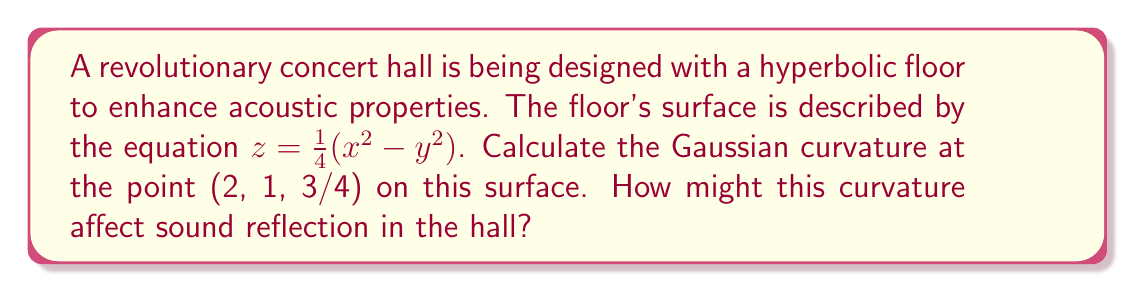Give your solution to this math problem. To calculate the Gaussian curvature of the hyperbolic surface, we'll follow these steps:

1) The surface is given by $z = f(x,y) = \frac{1}{4}(x^2 - y^2)$

2) We need to calculate the partial derivatives:
   $f_x = \frac{\partial f}{\partial x} = \frac{1}{2}x$
   $f_y = \frac{\partial f}{\partial y} = -\frac{1}{2}y$
   $f_{xx} = \frac{\partial^2 f}{\partial x^2} = \frac{1}{2}$
   $f_{yy} = \frac{\partial^2 f}{\partial y^2} = -\frac{1}{2}$
   $f_{xy} = f_{yx} = \frac{\partial^2 f}{\partial x \partial y} = 0$

3) The Gaussian curvature K is given by:
   $$K = \frac{f_{xx}f_{yy} - f_{xy}^2}{(1 + f_x^2 + f_y^2)^2}$$

4) Substituting the values at point (2, 1, 3/4):
   $$K = \frac{(\frac{1}{2})(-\frac{1}{2}) - 0^2}{(1 + (1)^2 + (-\frac{1}{2})^2)^2}$$

5) Simplifying:
   $$K = \frac{-\frac{1}{4}}{(1 + 1 + \frac{1}{4})^2} = \frac{-\frac{1}{4}}{(\frac{9}{4})^2} = -\frac{4}{81}$$

The negative curvature indicates that the surface is saddle-shaped at this point. This hyperbolic curvature can help disperse sound waves in multiple directions, potentially improving acoustic distribution throughout the concert hall. It may also reduce unwanted echoes and create a more immersive sound experience for the audience.
Answer: $K = -\frac{4}{81}$ 